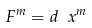Convert formula to latex. <formula><loc_0><loc_0><loc_500><loc_500>F ^ { m } = d \ x ^ { m }</formula> 